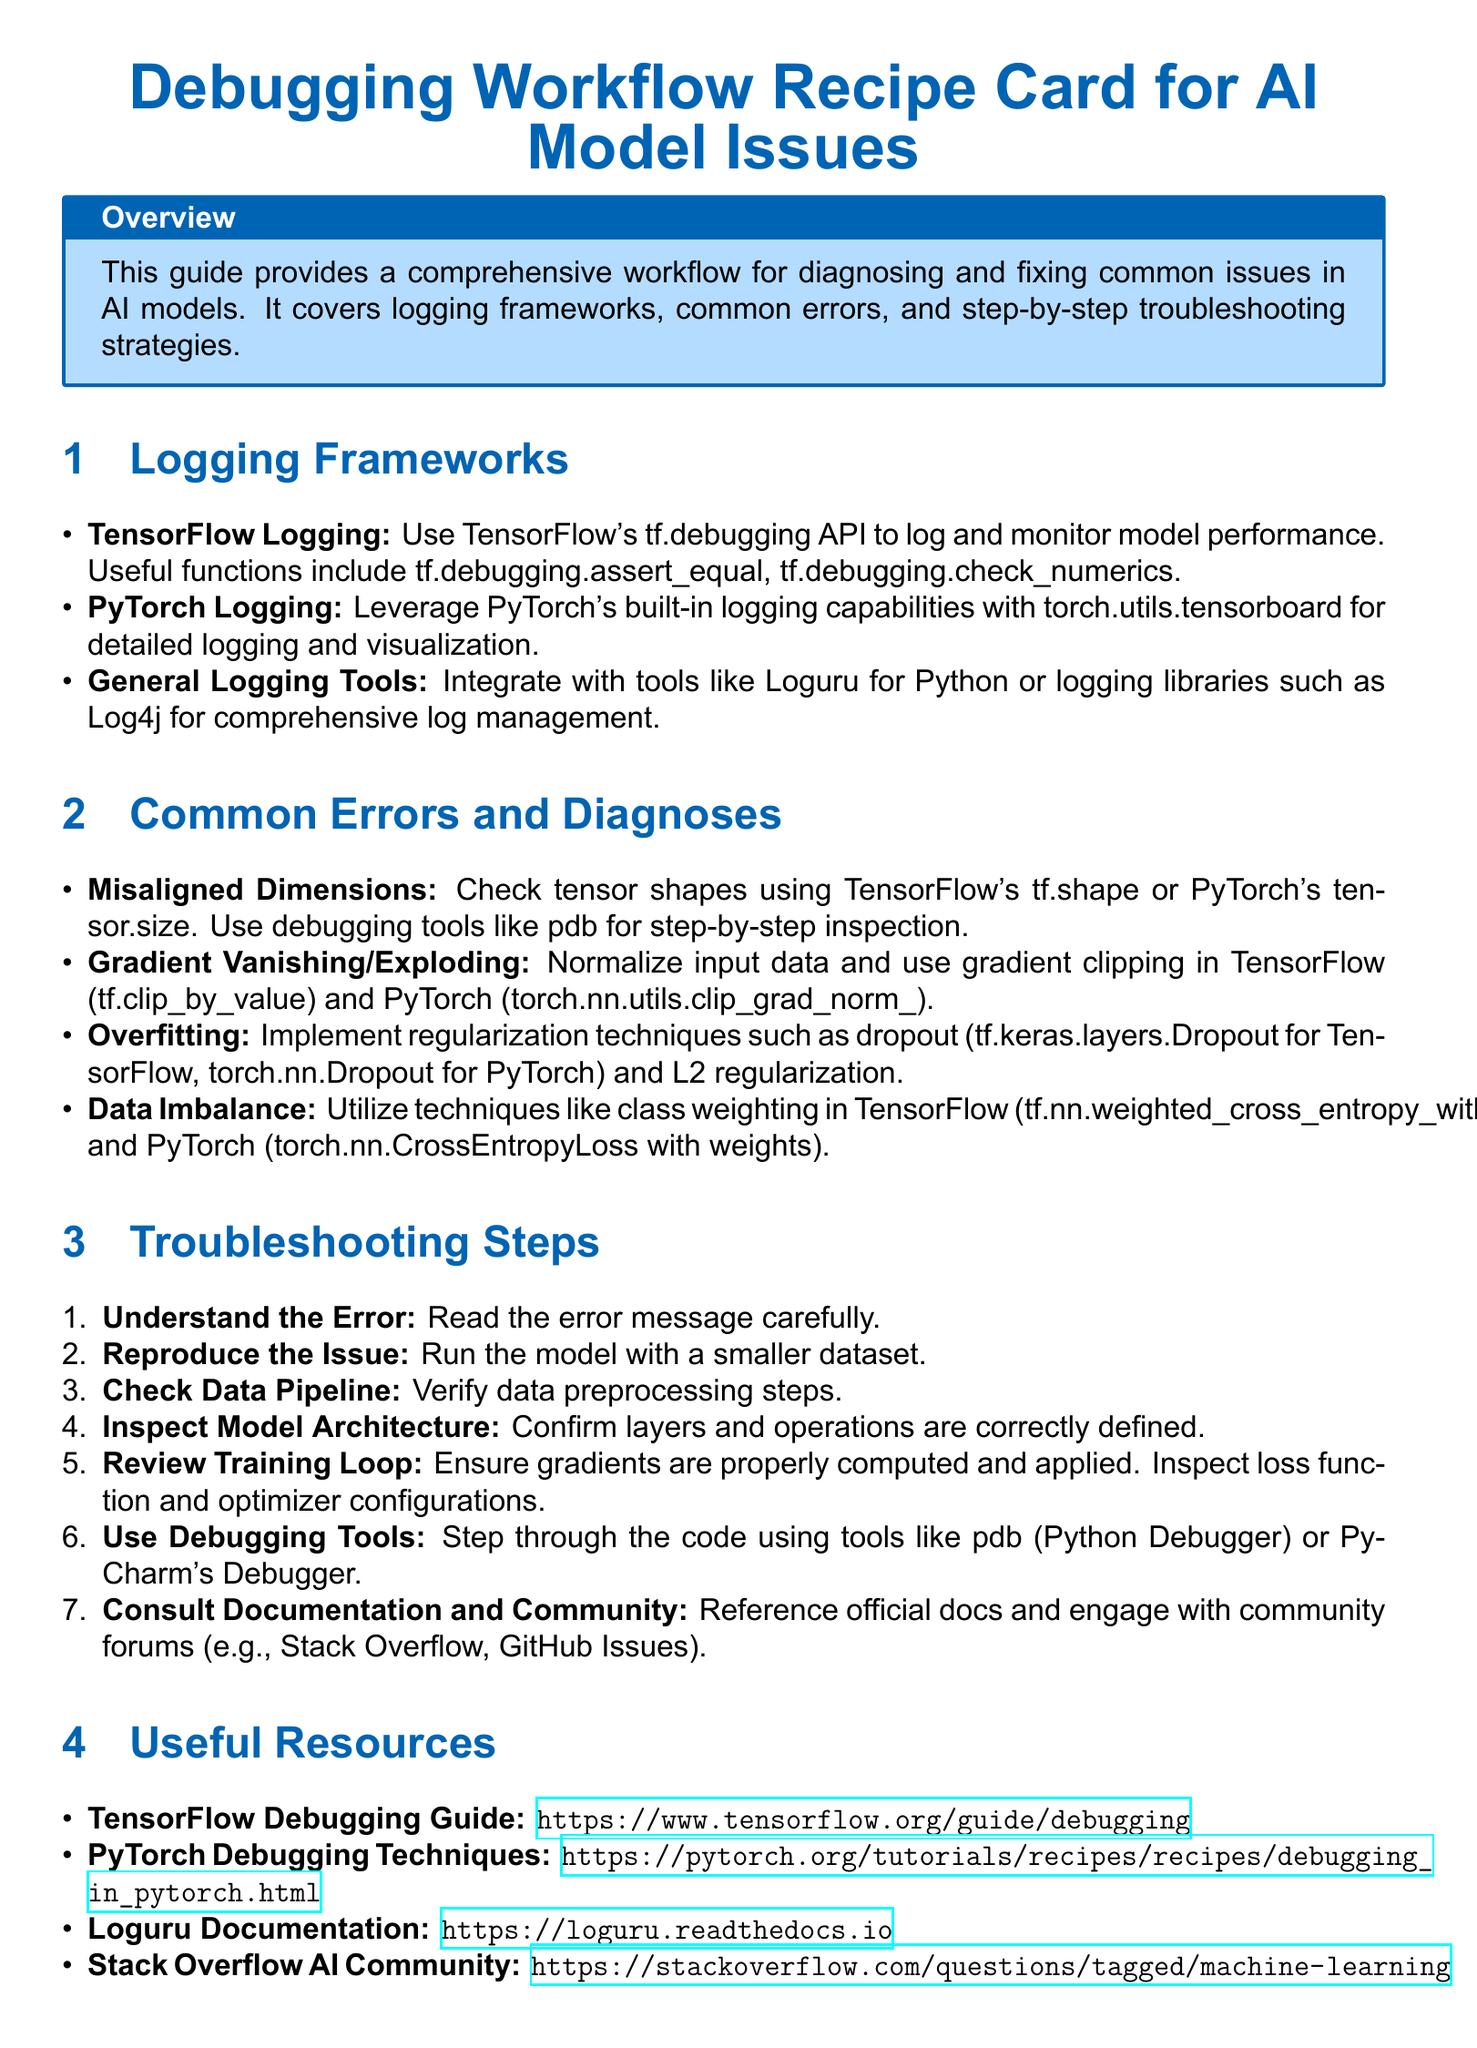What is the title of the document? The title provides the main subject of the document, which is "Debugging Workflow Recipe Card for AI Model Issues."
Answer: Debugging Workflow Recipe Card for AI Model Issues What logging framework is mentioned for TensorFlow? The document specifies using TensorFlow's tf.debugging API for logging and monitoring.
Answer: tf.debugging API What common error involves checking tensor shapes? The document refers to the "Misaligned Dimensions" error as related to checking tensor shapes.
Answer: Misaligned Dimensions How many troubleshooting steps are listed? The document enumerates the troubleshooting steps for diagnosing AI model issues, totaling 7.
Answer: 7 What tool can be used for step-by-step code inspection? The document mentions using pdb (Python Debugger) for inspecting code step-by-step.
Answer: pdb What is one technique to address overfitting mentioned in the document? The document lists implementing dropout as one method to combat overfitting in AI models.
Answer: Dropout What type of community resource is suggested for consultation? The document directs users to engage with community forums, specifically mentioning Stack Overflow.
Answer: Stack Overflow 